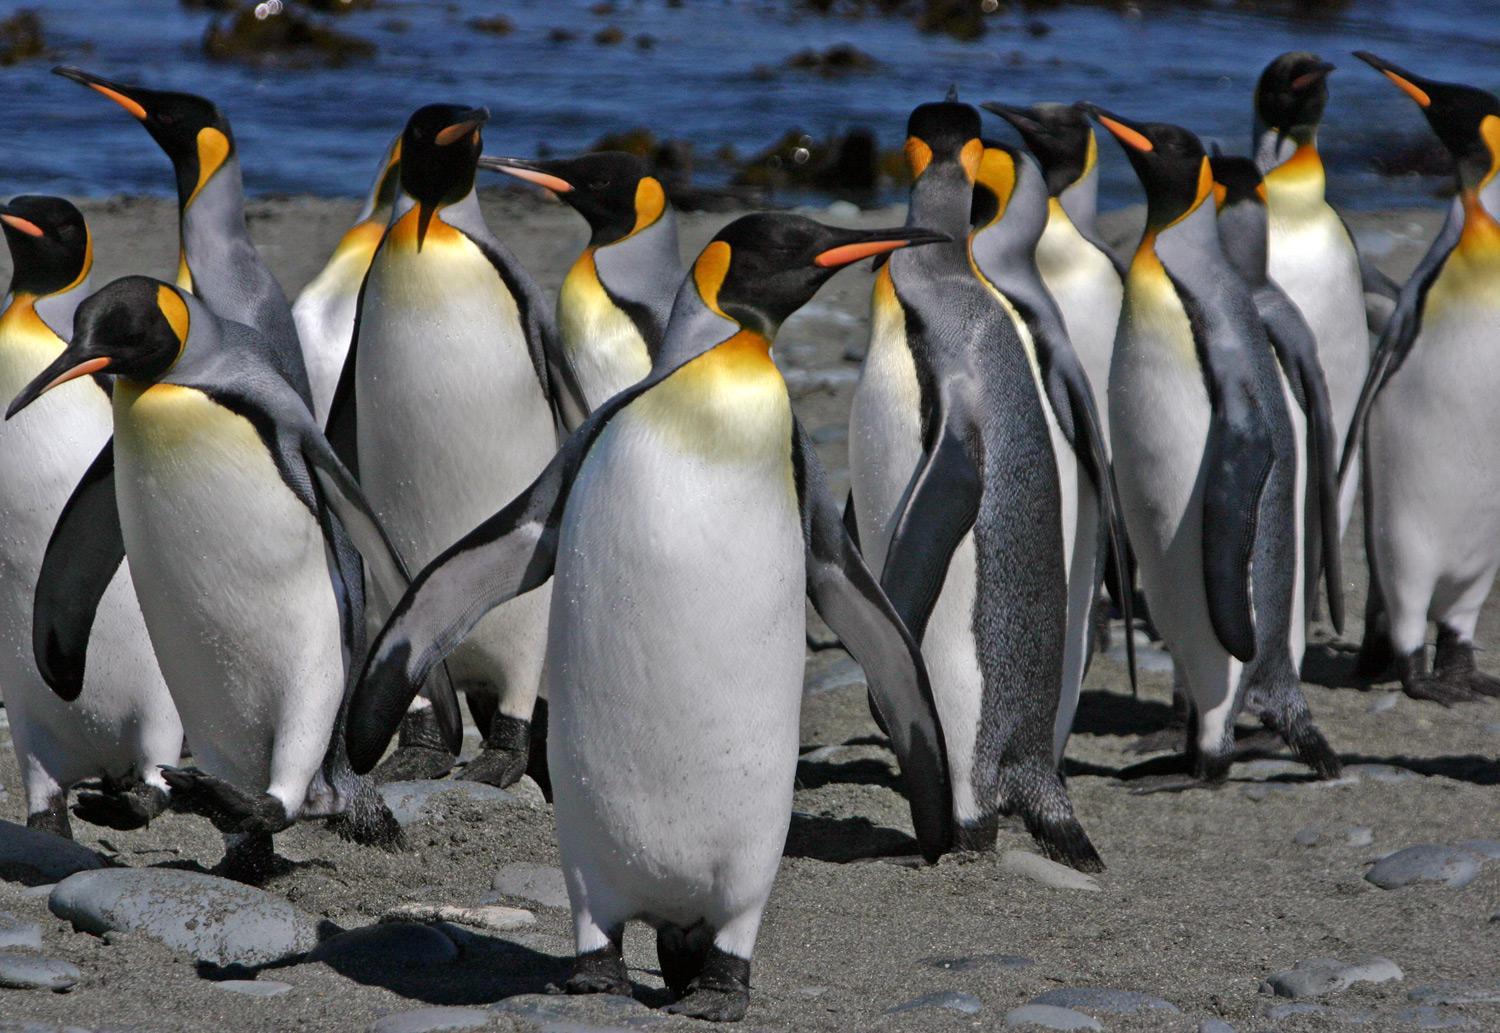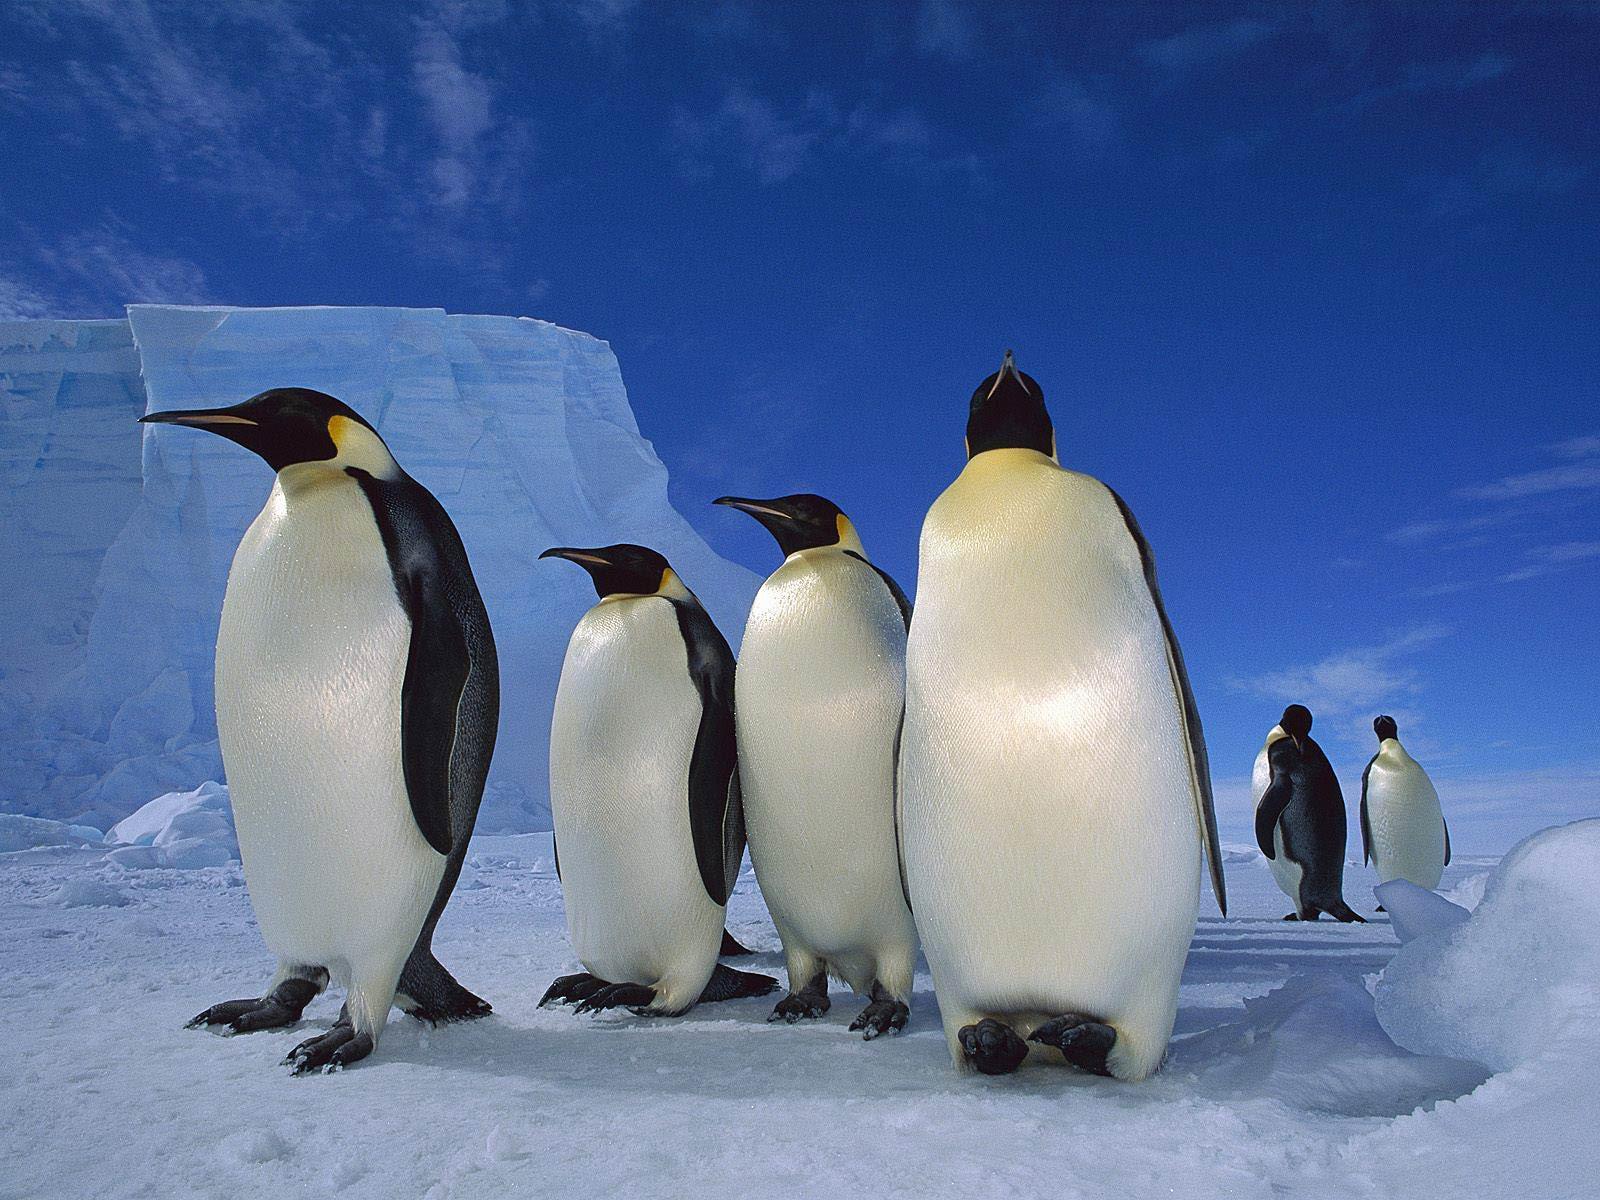The first image is the image on the left, the second image is the image on the right. Considering the images on both sides, is "A waddle of penguins is standing in a snowy landscape in one of the images." valid? Answer yes or no. Yes. 